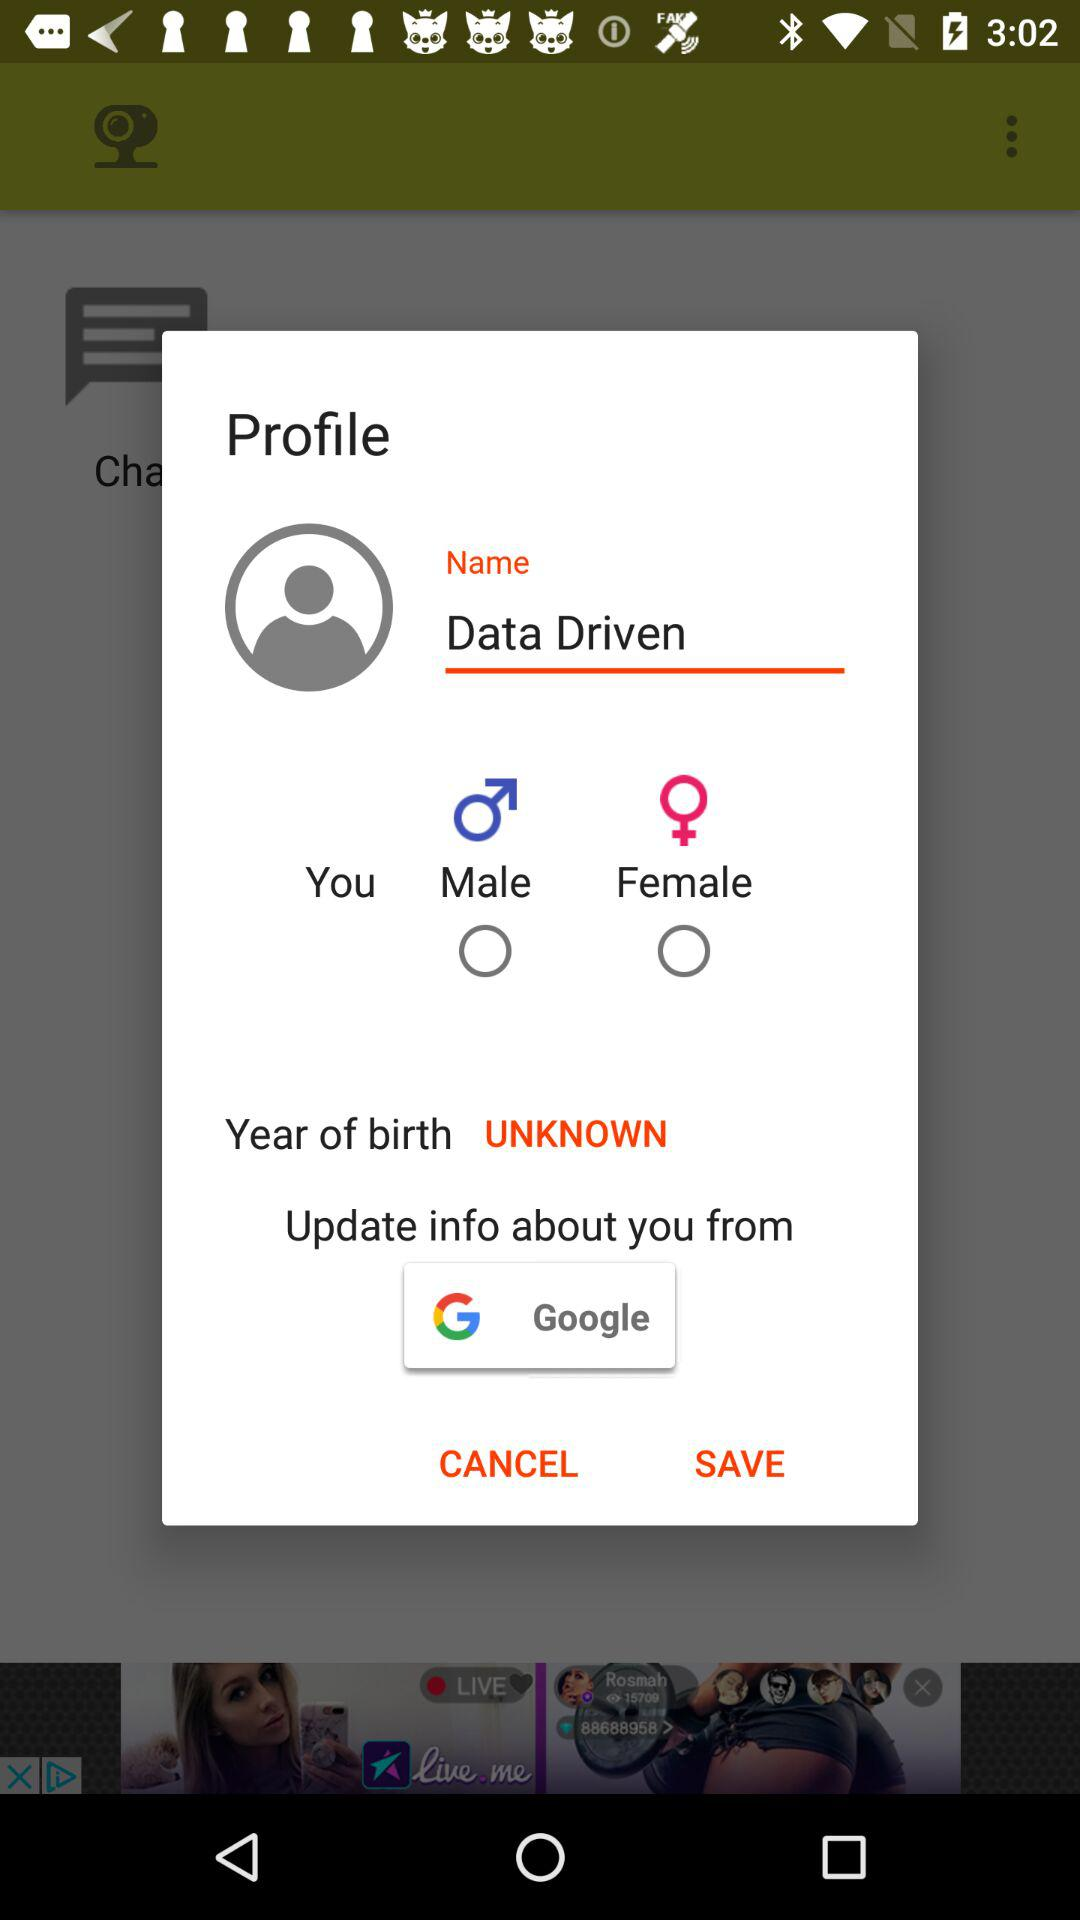What is the name of the user? The name of the user is Data Driven. 